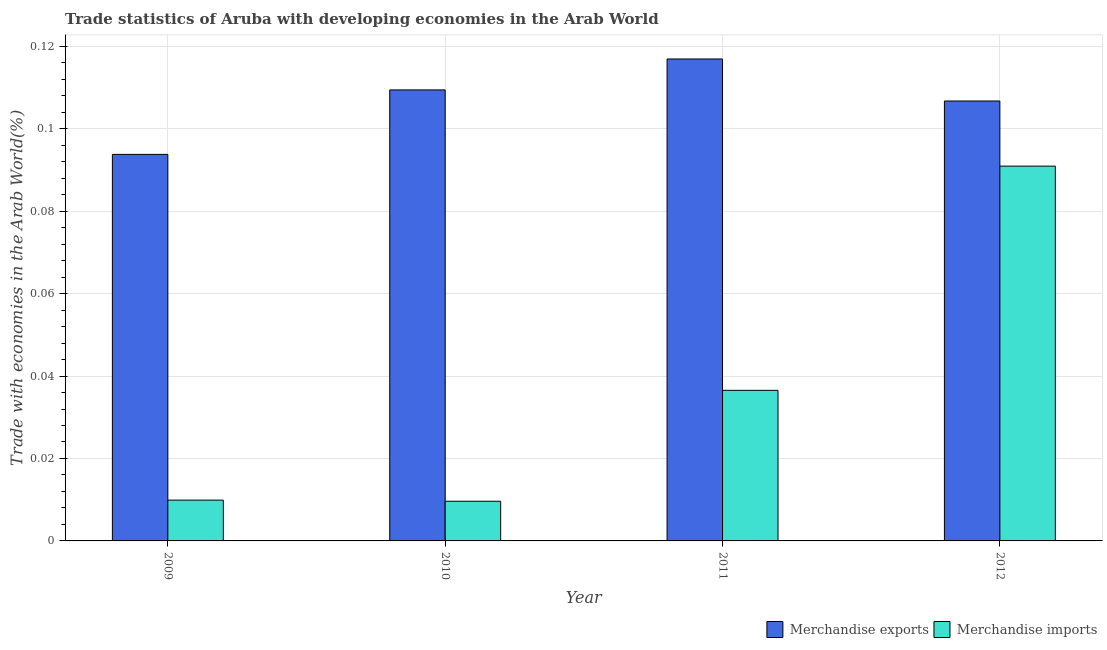How many groups of bars are there?
Your answer should be compact. 4. Are the number of bars per tick equal to the number of legend labels?
Your answer should be very brief. Yes. How many bars are there on the 3rd tick from the right?
Ensure brevity in your answer.  2. What is the merchandise exports in 2009?
Provide a short and direct response. 0.09. Across all years, what is the maximum merchandise imports?
Your answer should be very brief. 0.09. Across all years, what is the minimum merchandise exports?
Offer a very short reply. 0.09. In which year was the merchandise exports maximum?
Provide a short and direct response. 2011. In which year was the merchandise imports minimum?
Provide a succinct answer. 2010. What is the total merchandise exports in the graph?
Offer a terse response. 0.43. What is the difference between the merchandise imports in 2010 and that in 2011?
Provide a short and direct response. -0.03. What is the difference between the merchandise exports in 2012 and the merchandise imports in 2011?
Ensure brevity in your answer.  -0.01. What is the average merchandise imports per year?
Give a very brief answer. 0.04. What is the ratio of the merchandise exports in 2010 to that in 2012?
Give a very brief answer. 1.03. What is the difference between the highest and the second highest merchandise exports?
Offer a very short reply. 0.01. What is the difference between the highest and the lowest merchandise exports?
Provide a short and direct response. 0.02. Is the sum of the merchandise exports in 2010 and 2012 greater than the maximum merchandise imports across all years?
Give a very brief answer. Yes. What does the 1st bar from the right in 2010 represents?
Your answer should be very brief. Merchandise imports. Are all the bars in the graph horizontal?
Make the answer very short. No. What is the difference between two consecutive major ticks on the Y-axis?
Provide a short and direct response. 0.02. Does the graph contain any zero values?
Ensure brevity in your answer.  No. Where does the legend appear in the graph?
Provide a short and direct response. Bottom right. How are the legend labels stacked?
Give a very brief answer. Horizontal. What is the title of the graph?
Keep it short and to the point. Trade statistics of Aruba with developing economies in the Arab World. What is the label or title of the X-axis?
Provide a succinct answer. Year. What is the label or title of the Y-axis?
Make the answer very short. Trade with economies in the Arab World(%). What is the Trade with economies in the Arab World(%) of Merchandise exports in 2009?
Offer a terse response. 0.09. What is the Trade with economies in the Arab World(%) in Merchandise imports in 2009?
Provide a succinct answer. 0.01. What is the Trade with economies in the Arab World(%) of Merchandise exports in 2010?
Provide a short and direct response. 0.11. What is the Trade with economies in the Arab World(%) in Merchandise imports in 2010?
Give a very brief answer. 0.01. What is the Trade with economies in the Arab World(%) in Merchandise exports in 2011?
Provide a succinct answer. 0.12. What is the Trade with economies in the Arab World(%) of Merchandise imports in 2011?
Give a very brief answer. 0.04. What is the Trade with economies in the Arab World(%) of Merchandise exports in 2012?
Provide a short and direct response. 0.11. What is the Trade with economies in the Arab World(%) of Merchandise imports in 2012?
Provide a short and direct response. 0.09. Across all years, what is the maximum Trade with economies in the Arab World(%) in Merchandise exports?
Your response must be concise. 0.12. Across all years, what is the maximum Trade with economies in the Arab World(%) of Merchandise imports?
Offer a terse response. 0.09. Across all years, what is the minimum Trade with economies in the Arab World(%) in Merchandise exports?
Your answer should be very brief. 0.09. Across all years, what is the minimum Trade with economies in the Arab World(%) of Merchandise imports?
Make the answer very short. 0.01. What is the total Trade with economies in the Arab World(%) of Merchandise exports in the graph?
Provide a short and direct response. 0.43. What is the total Trade with economies in the Arab World(%) in Merchandise imports in the graph?
Offer a very short reply. 0.15. What is the difference between the Trade with economies in the Arab World(%) of Merchandise exports in 2009 and that in 2010?
Give a very brief answer. -0.02. What is the difference between the Trade with economies in the Arab World(%) of Merchandise exports in 2009 and that in 2011?
Keep it short and to the point. -0.02. What is the difference between the Trade with economies in the Arab World(%) in Merchandise imports in 2009 and that in 2011?
Your answer should be compact. -0.03. What is the difference between the Trade with economies in the Arab World(%) in Merchandise exports in 2009 and that in 2012?
Offer a very short reply. -0.01. What is the difference between the Trade with economies in the Arab World(%) in Merchandise imports in 2009 and that in 2012?
Make the answer very short. -0.08. What is the difference between the Trade with economies in the Arab World(%) in Merchandise exports in 2010 and that in 2011?
Offer a very short reply. -0.01. What is the difference between the Trade with economies in the Arab World(%) in Merchandise imports in 2010 and that in 2011?
Ensure brevity in your answer.  -0.03. What is the difference between the Trade with economies in the Arab World(%) of Merchandise exports in 2010 and that in 2012?
Give a very brief answer. 0. What is the difference between the Trade with economies in the Arab World(%) in Merchandise imports in 2010 and that in 2012?
Your response must be concise. -0.08. What is the difference between the Trade with economies in the Arab World(%) of Merchandise exports in 2011 and that in 2012?
Offer a very short reply. 0.01. What is the difference between the Trade with economies in the Arab World(%) of Merchandise imports in 2011 and that in 2012?
Your answer should be compact. -0.05. What is the difference between the Trade with economies in the Arab World(%) in Merchandise exports in 2009 and the Trade with economies in the Arab World(%) in Merchandise imports in 2010?
Provide a short and direct response. 0.08. What is the difference between the Trade with economies in the Arab World(%) in Merchandise exports in 2009 and the Trade with economies in the Arab World(%) in Merchandise imports in 2011?
Your answer should be very brief. 0.06. What is the difference between the Trade with economies in the Arab World(%) in Merchandise exports in 2009 and the Trade with economies in the Arab World(%) in Merchandise imports in 2012?
Offer a terse response. 0. What is the difference between the Trade with economies in the Arab World(%) in Merchandise exports in 2010 and the Trade with economies in the Arab World(%) in Merchandise imports in 2011?
Your answer should be compact. 0.07. What is the difference between the Trade with economies in the Arab World(%) of Merchandise exports in 2010 and the Trade with economies in the Arab World(%) of Merchandise imports in 2012?
Provide a short and direct response. 0.02. What is the difference between the Trade with economies in the Arab World(%) in Merchandise exports in 2011 and the Trade with economies in the Arab World(%) in Merchandise imports in 2012?
Offer a very short reply. 0.03. What is the average Trade with economies in the Arab World(%) of Merchandise exports per year?
Give a very brief answer. 0.11. What is the average Trade with economies in the Arab World(%) of Merchandise imports per year?
Provide a short and direct response. 0.04. In the year 2009, what is the difference between the Trade with economies in the Arab World(%) of Merchandise exports and Trade with economies in the Arab World(%) of Merchandise imports?
Keep it short and to the point. 0.08. In the year 2010, what is the difference between the Trade with economies in the Arab World(%) in Merchandise exports and Trade with economies in the Arab World(%) in Merchandise imports?
Offer a terse response. 0.1. In the year 2011, what is the difference between the Trade with economies in the Arab World(%) of Merchandise exports and Trade with economies in the Arab World(%) of Merchandise imports?
Provide a succinct answer. 0.08. In the year 2012, what is the difference between the Trade with economies in the Arab World(%) in Merchandise exports and Trade with economies in the Arab World(%) in Merchandise imports?
Give a very brief answer. 0.02. What is the ratio of the Trade with economies in the Arab World(%) of Merchandise exports in 2009 to that in 2010?
Offer a terse response. 0.86. What is the ratio of the Trade with economies in the Arab World(%) in Merchandise imports in 2009 to that in 2010?
Provide a succinct answer. 1.03. What is the ratio of the Trade with economies in the Arab World(%) of Merchandise exports in 2009 to that in 2011?
Make the answer very short. 0.8. What is the ratio of the Trade with economies in the Arab World(%) in Merchandise imports in 2009 to that in 2011?
Your answer should be compact. 0.27. What is the ratio of the Trade with economies in the Arab World(%) in Merchandise exports in 2009 to that in 2012?
Offer a terse response. 0.88. What is the ratio of the Trade with economies in the Arab World(%) in Merchandise imports in 2009 to that in 2012?
Your answer should be compact. 0.11. What is the ratio of the Trade with economies in the Arab World(%) of Merchandise exports in 2010 to that in 2011?
Give a very brief answer. 0.94. What is the ratio of the Trade with economies in the Arab World(%) in Merchandise imports in 2010 to that in 2011?
Your answer should be compact. 0.26. What is the ratio of the Trade with economies in the Arab World(%) of Merchandise exports in 2010 to that in 2012?
Keep it short and to the point. 1.03. What is the ratio of the Trade with economies in the Arab World(%) of Merchandise imports in 2010 to that in 2012?
Offer a terse response. 0.11. What is the ratio of the Trade with economies in the Arab World(%) of Merchandise exports in 2011 to that in 2012?
Your response must be concise. 1.1. What is the ratio of the Trade with economies in the Arab World(%) in Merchandise imports in 2011 to that in 2012?
Offer a very short reply. 0.4. What is the difference between the highest and the second highest Trade with economies in the Arab World(%) in Merchandise exports?
Offer a terse response. 0.01. What is the difference between the highest and the second highest Trade with economies in the Arab World(%) of Merchandise imports?
Offer a terse response. 0.05. What is the difference between the highest and the lowest Trade with economies in the Arab World(%) in Merchandise exports?
Make the answer very short. 0.02. What is the difference between the highest and the lowest Trade with economies in the Arab World(%) of Merchandise imports?
Provide a short and direct response. 0.08. 